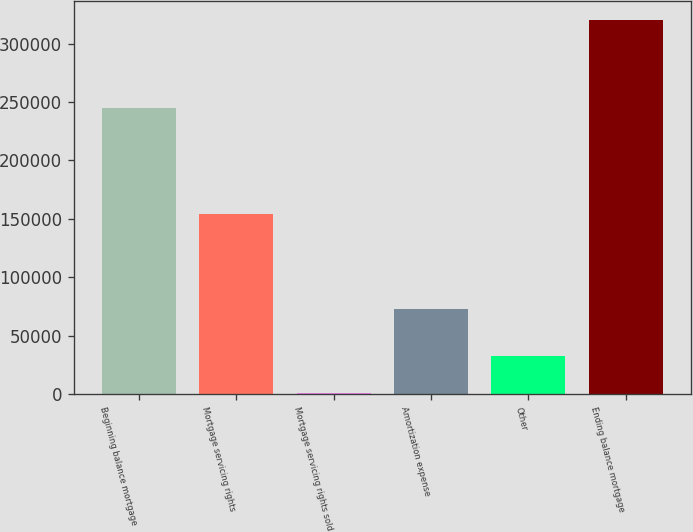<chart> <loc_0><loc_0><loc_500><loc_500><bar_chart><fcel>Beginning balance mortgage<fcel>Mortgage servicing rights<fcel>Mortgage servicing rights sold<fcel>Amortization expense<fcel>Other<fcel>Ending balance mortgage<nl><fcel>244723<fcel>154040<fcel>790<fcel>73273<fcel>32763.4<fcel>320524<nl></chart> 